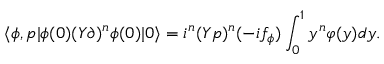Convert formula to latex. <formula><loc_0><loc_0><loc_500><loc_500>\langle \phi , { p } | \phi ( 0 ) ( Y \partial ) ^ { n } \phi ( 0 ) | 0 \rangle = i ^ { n } ( Y p ) ^ { n } ( - i f _ { \phi } ) \int _ { 0 } ^ { 1 } y ^ { n } \varphi ( y ) d y .</formula> 